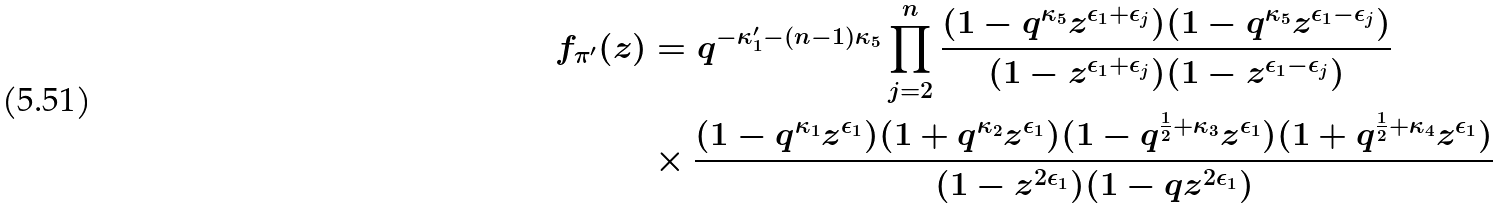Convert formula to latex. <formula><loc_0><loc_0><loc_500><loc_500>f _ { \pi ^ { \prime } } ( z ) & = q ^ { - \kappa _ { 1 } ^ { \prime } - ( n - 1 ) \kappa _ { 5 } } \prod _ { j = 2 } ^ { n } \frac { ( 1 - q ^ { \kappa _ { 5 } } z ^ { \epsilon _ { 1 } + \epsilon _ { j } } ) ( 1 - q ^ { \kappa _ { 5 } } z ^ { \epsilon _ { 1 } - \epsilon _ { j } } ) } { ( 1 - z ^ { \epsilon _ { 1 } + \epsilon _ { j } } ) ( 1 - z ^ { \epsilon _ { 1 } - \epsilon _ { j } } ) } \\ & \times \frac { ( 1 - q ^ { \kappa _ { 1 } } z ^ { \epsilon _ { 1 } } ) ( 1 + q ^ { \kappa _ { 2 } } z ^ { \epsilon _ { 1 } } ) ( 1 - q ^ { \frac { 1 } { 2 } + \kappa _ { 3 } } z ^ { \epsilon _ { 1 } } ) ( 1 + q ^ { \frac { 1 } { 2 } + \kappa _ { 4 } } z ^ { \epsilon _ { 1 } } ) } { ( 1 - z ^ { 2 \epsilon _ { 1 } } ) ( 1 - q z ^ { 2 \epsilon _ { 1 } } ) }</formula> 